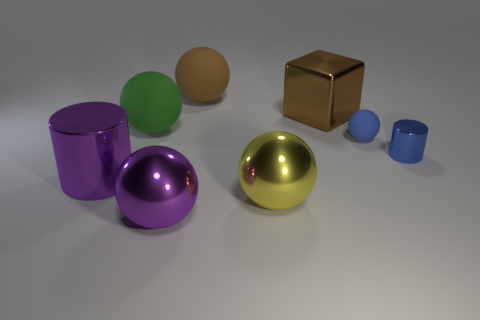Subtract all large spheres. How many spheres are left? 1 Subtract 2 spheres. How many spheres are left? 3 Subtract all brown balls. How many balls are left? 4 Subtract all red balls. Subtract all gray blocks. How many balls are left? 5 Add 1 large cylinders. How many objects exist? 9 Subtract all cylinders. How many objects are left? 6 Add 7 shiny balls. How many shiny balls exist? 9 Subtract 0 cyan blocks. How many objects are left? 8 Subtract all green rubber spheres. Subtract all yellow shiny balls. How many objects are left? 6 Add 4 tiny metallic things. How many tiny metallic things are left? 5 